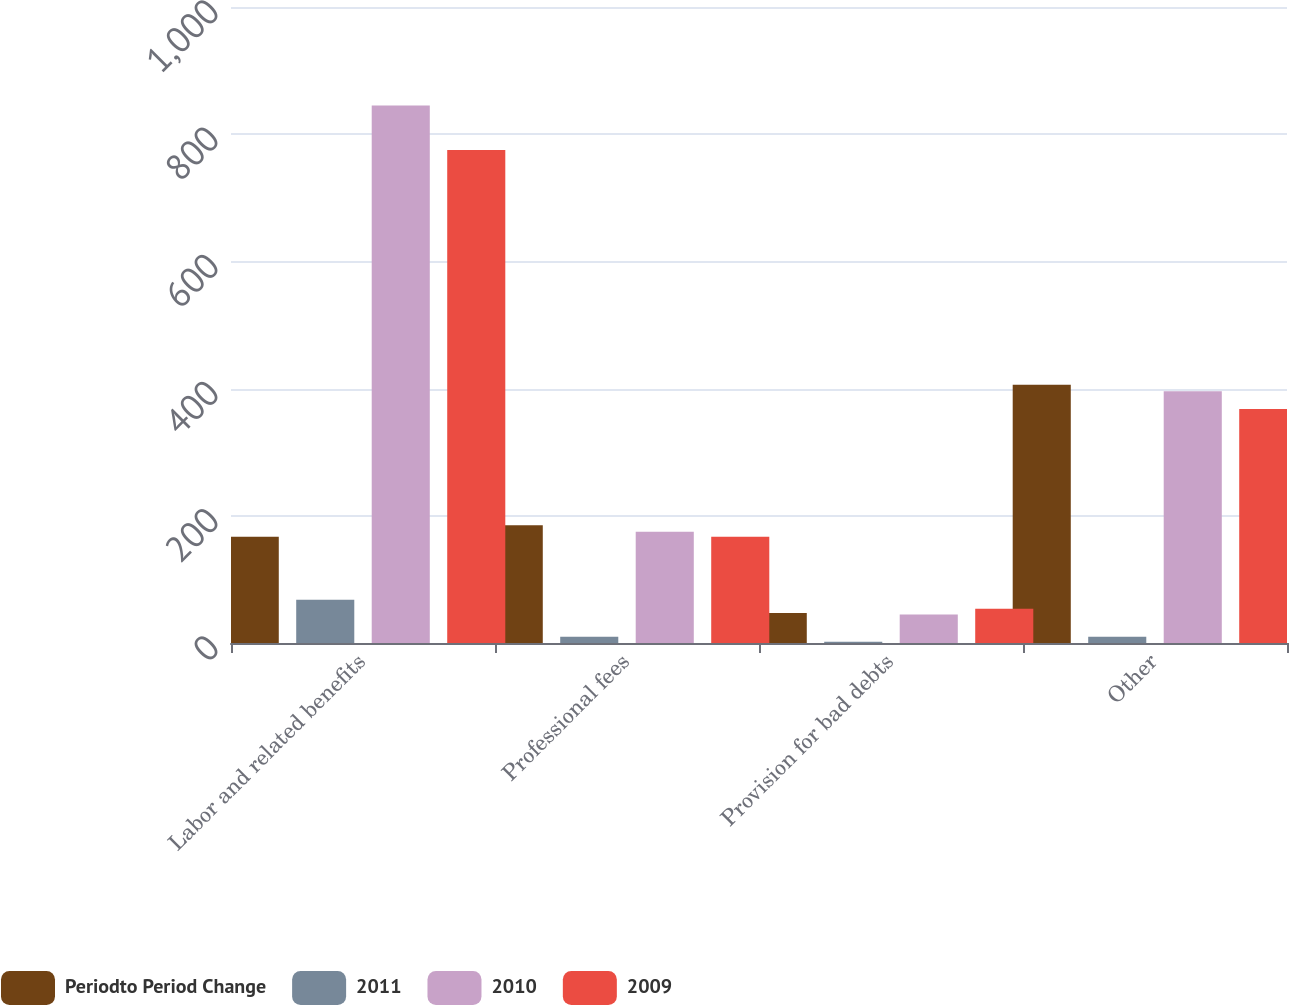Convert chart to OTSL. <chart><loc_0><loc_0><loc_500><loc_500><stacked_bar_chart><ecel><fcel>Labor and related benefits<fcel>Professional fees<fcel>Provision for bad debts<fcel>Other<nl><fcel>Periodto Period Change<fcel>167<fcel>185<fcel>47<fcel>406<nl><fcel>2011<fcel>68<fcel>10<fcel>2<fcel>10<nl><fcel>2010<fcel>845<fcel>175<fcel>45<fcel>396<nl><fcel>2009<fcel>775<fcel>167<fcel>54<fcel>368<nl></chart> 